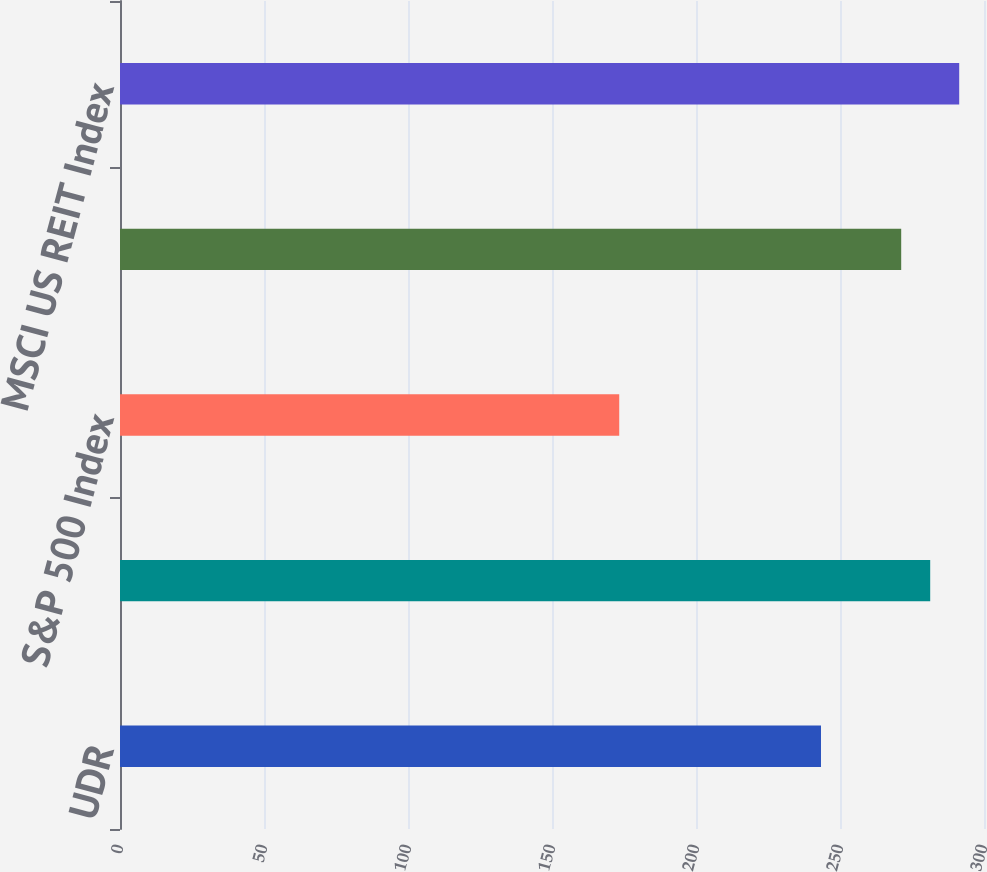<chart> <loc_0><loc_0><loc_500><loc_500><bar_chart><fcel>UDR<fcel>NAREIT Equity REIT Index<fcel>S&P 500 Index<fcel>NAREIT Equity Apartment Index<fcel>MSCI US REIT Index<nl><fcel>243.4<fcel>281.32<fcel>173.34<fcel>271.25<fcel>291.39<nl></chart> 